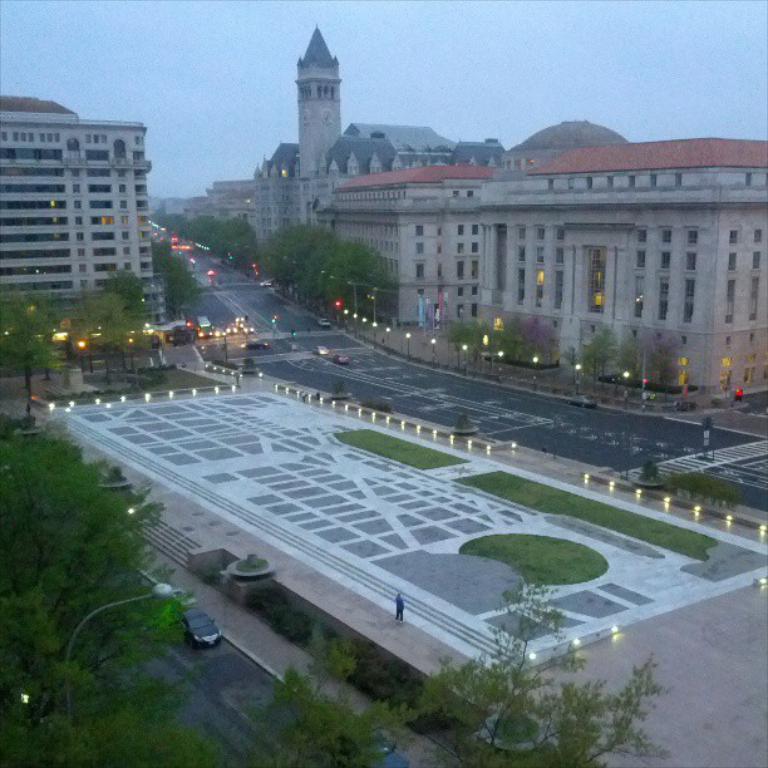Describe this image in one or two sentences. In this image I can see a road and I can see buildings visible at the top I can see the sky and I can see trees visible on the left side and I can see lights visible in the middle. 